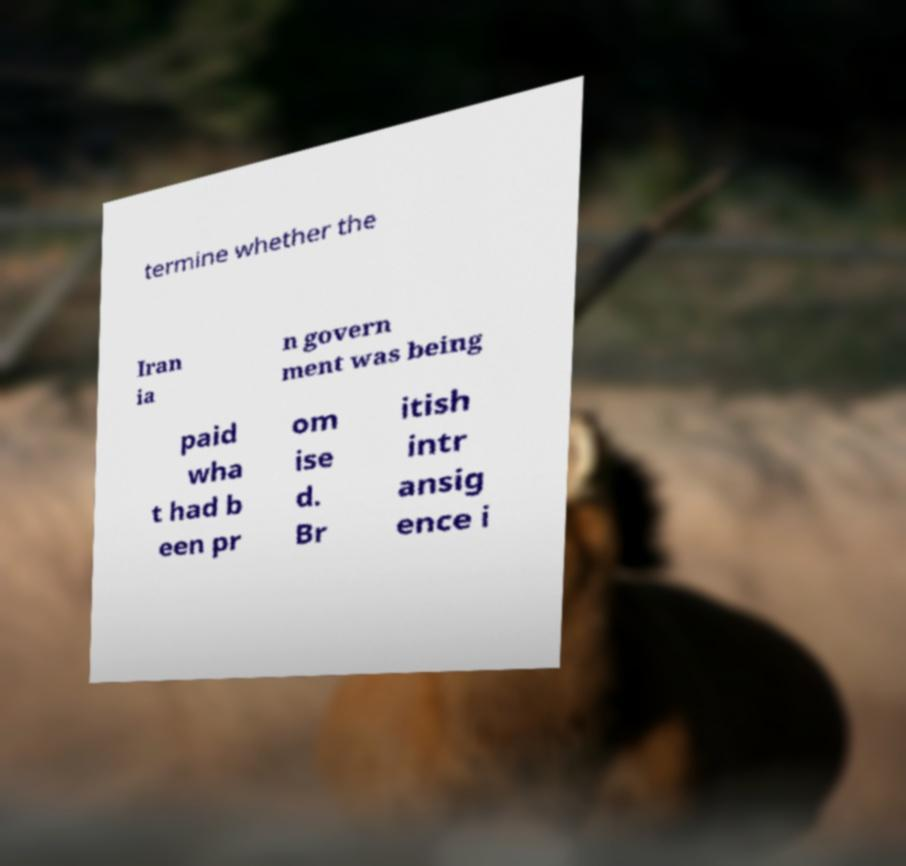What messages or text are displayed in this image? I need them in a readable, typed format. termine whether the Iran ia n govern ment was being paid wha t had b een pr om ise d. Br itish intr ansig ence i 